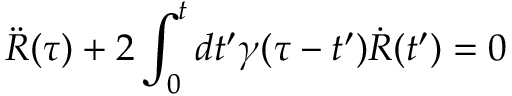<formula> <loc_0><loc_0><loc_500><loc_500>\ddot { R } ( \tau ) + 2 \int _ { 0 } ^ { t } { d t ^ { \prime } } \gamma ( \tau - t ^ { \prime } ) \dot { R } ( t ^ { \prime } ) = 0</formula> 